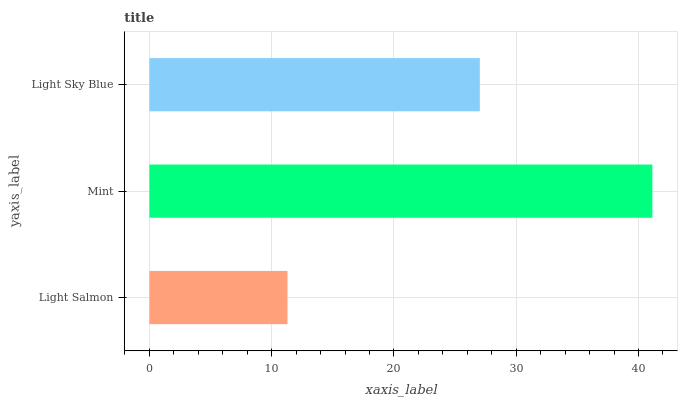Is Light Salmon the minimum?
Answer yes or no. Yes. Is Mint the maximum?
Answer yes or no. Yes. Is Light Sky Blue the minimum?
Answer yes or no. No. Is Light Sky Blue the maximum?
Answer yes or no. No. Is Mint greater than Light Sky Blue?
Answer yes or no. Yes. Is Light Sky Blue less than Mint?
Answer yes or no. Yes. Is Light Sky Blue greater than Mint?
Answer yes or no. No. Is Mint less than Light Sky Blue?
Answer yes or no. No. Is Light Sky Blue the high median?
Answer yes or no. Yes. Is Light Sky Blue the low median?
Answer yes or no. Yes. Is Mint the high median?
Answer yes or no. No. Is Mint the low median?
Answer yes or no. No. 